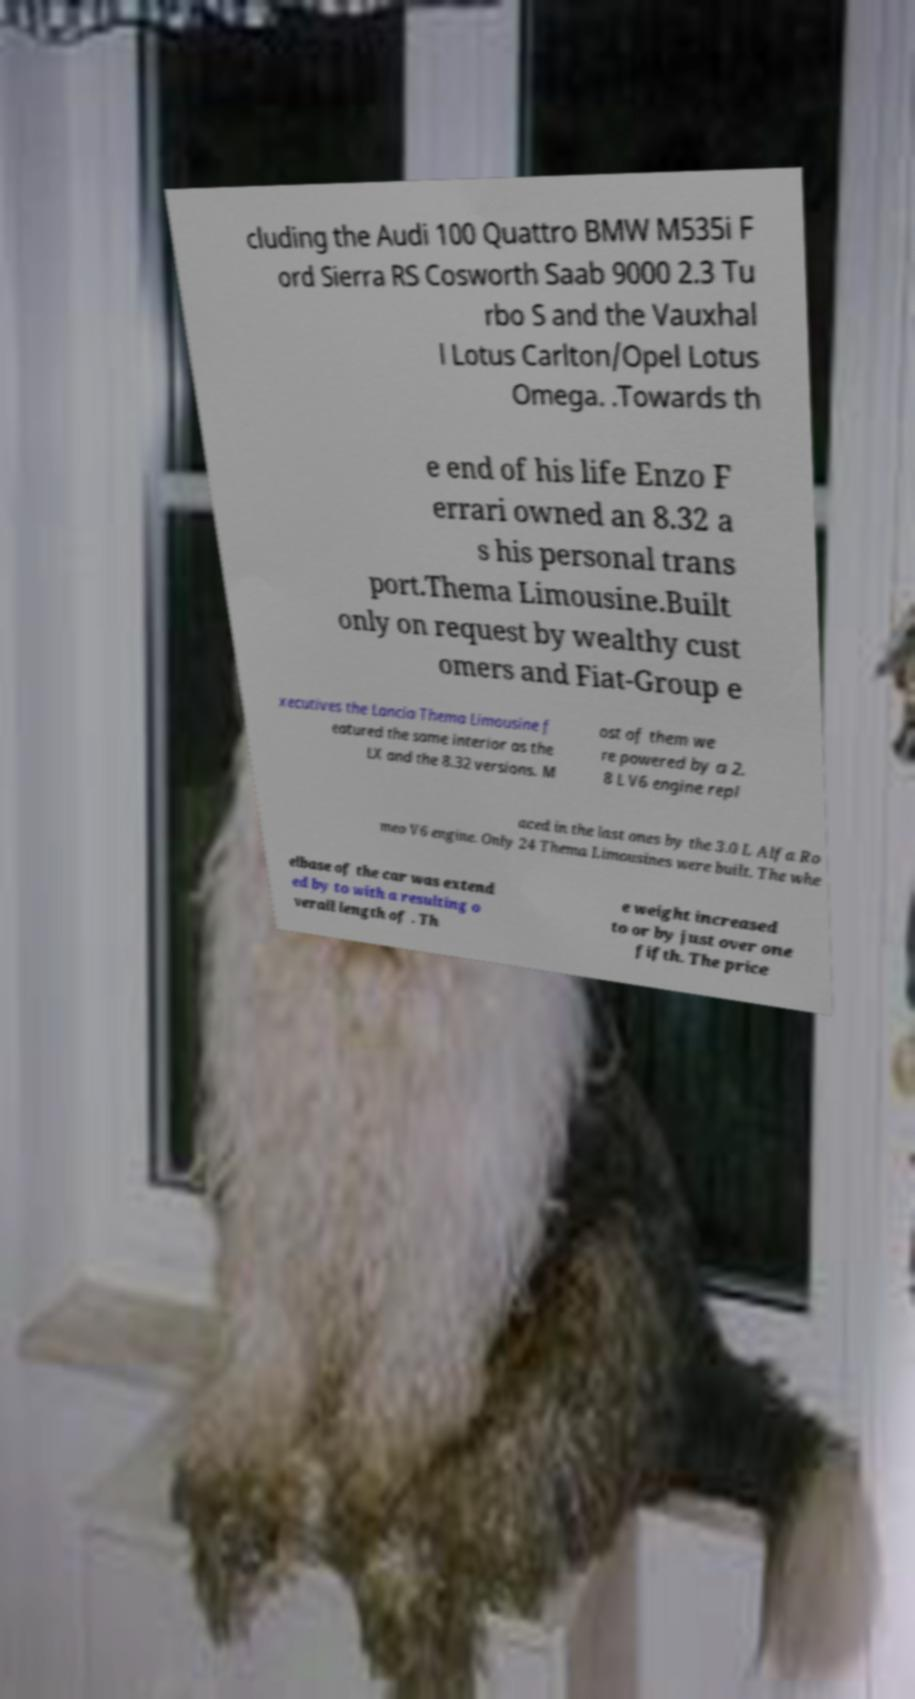Can you accurately transcribe the text from the provided image for me? cluding the Audi 100 Quattro BMW M535i F ord Sierra RS Cosworth Saab 9000 2.3 Tu rbo S and the Vauxhal l Lotus Carlton/Opel Lotus Omega. .Towards th e end of his life Enzo F errari owned an 8.32 a s his personal trans port.Thema Limousine.Built only on request by wealthy cust omers and Fiat-Group e xecutives the Lancia Thema Limousine f eatured the same interior as the LX and the 8.32 versions. M ost of them we re powered by a 2. 8 L V6 engine repl aced in the last ones by the 3.0 L Alfa Ro meo V6 engine. Only 24 Thema Limousines were built. The whe elbase of the car was extend ed by to with a resulting o verall length of . Th e weight increased to or by just over one fifth. The price 